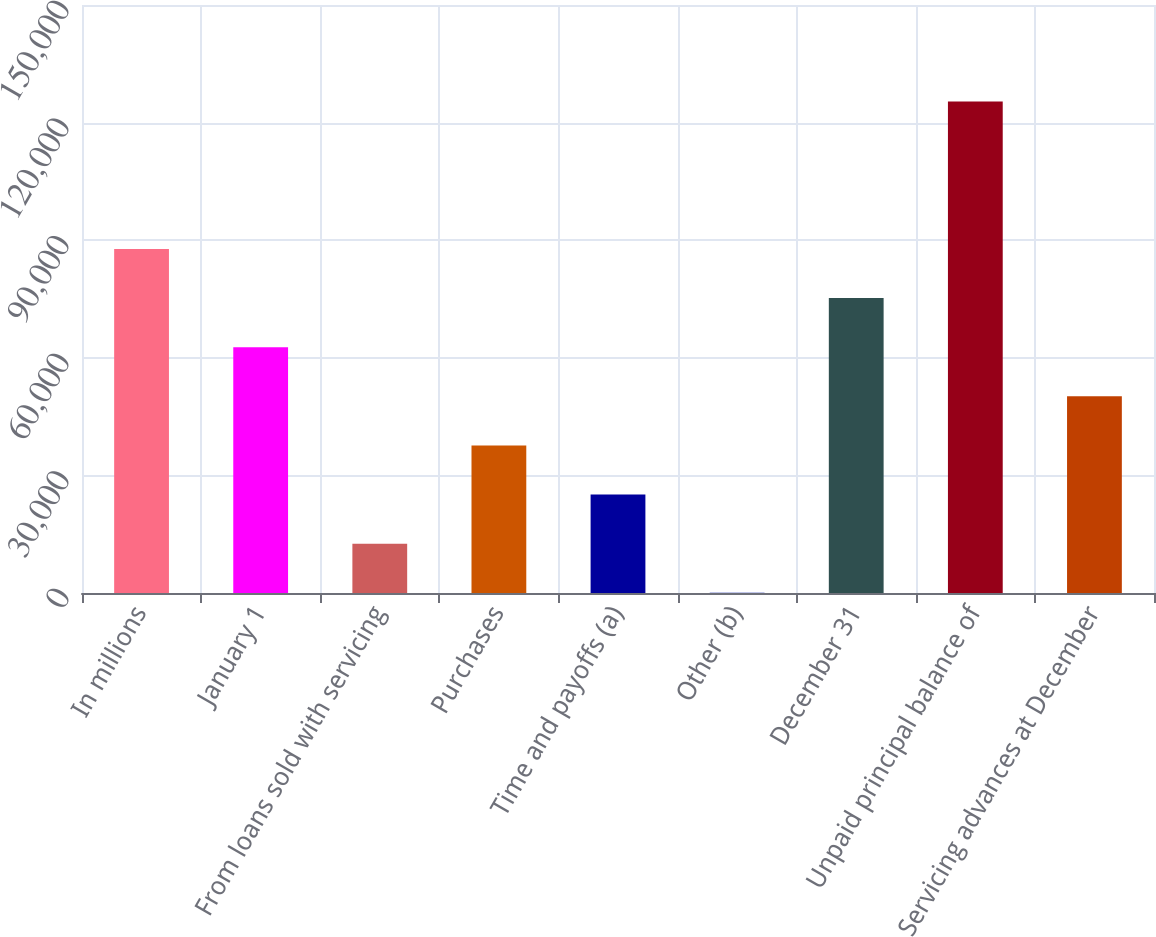<chart> <loc_0><loc_0><loc_500><loc_500><bar_chart><fcel>In millions<fcel>January 1<fcel>From loans sold with servicing<fcel>Purchases<fcel>Time and payoffs (a)<fcel>Other (b)<fcel>December 31<fcel>Unpaid principal balance of<fcel>Servicing advances at December<nl><fcel>87777.8<fcel>62709<fcel>12571.4<fcel>37640.2<fcel>25105.8<fcel>37<fcel>75243.4<fcel>125381<fcel>50174.6<nl></chart> 